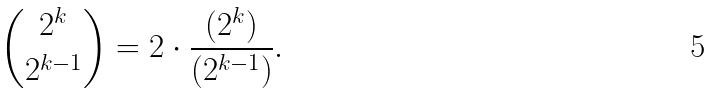Convert formula to latex. <formula><loc_0><loc_0><loc_500><loc_500>{ 2 ^ { k } \choose 2 ^ { k - 1 } } = 2 \cdot \frac { ( 2 ^ { k } ) } { ( 2 ^ { k - 1 } ) } .</formula> 